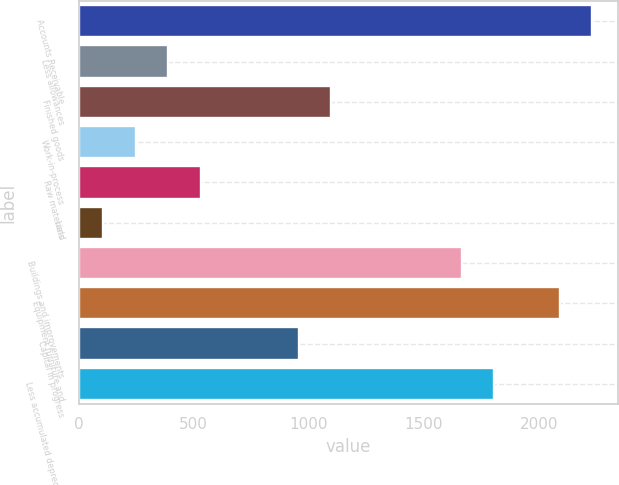Convert chart. <chart><loc_0><loc_0><loc_500><loc_500><bar_chart><fcel>Accounts Receivable<fcel>Less allowances<fcel>Finished goods<fcel>Work-in-process<fcel>Raw materials<fcel>Land<fcel>Buildings and improvements<fcel>Equipment furniture and<fcel>Capital in progress<fcel>Less accumulated depreciation<nl><fcel>2231<fcel>390.2<fcel>1098.2<fcel>248.6<fcel>531.8<fcel>107<fcel>1664.6<fcel>2089.4<fcel>956.6<fcel>1806.2<nl></chart> 